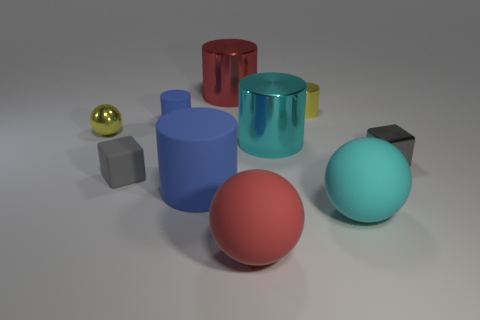Subtract 2 cylinders. How many cylinders are left? 3 Subtract all tiny blue matte cylinders. How many cylinders are left? 4 Subtract all brown cylinders. Subtract all red blocks. How many cylinders are left? 5 Subtract all spheres. How many objects are left? 7 Subtract all purple metal objects. Subtract all tiny yellow metallic spheres. How many objects are left? 9 Add 9 rubber blocks. How many rubber blocks are left? 10 Add 7 tiny red rubber balls. How many tiny red rubber balls exist? 7 Subtract 1 gray cubes. How many objects are left? 9 